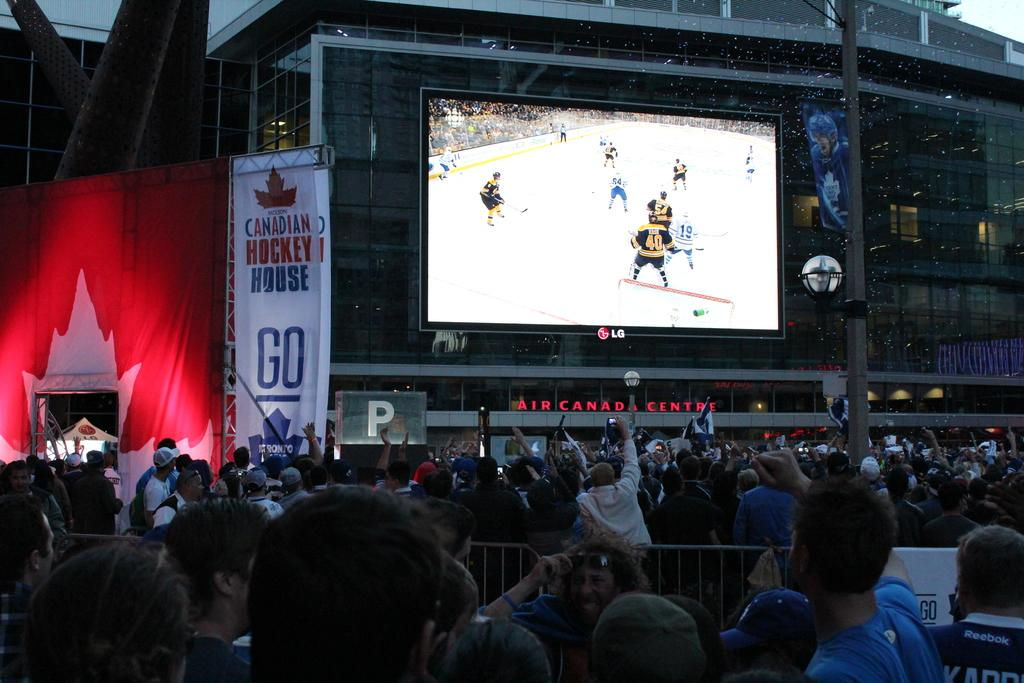What is the main subject in the foreground of the image? There is a crowd in the foreground of the image. Where is the crowd located? The crowd is on the road. What is present in the foreground of the image besides the crowd? There is a fence in the foreground of the image. What can be seen in the background of the image? There is a screen, buildings, a poster, and the sky visible in the background of the image. What type of grass is growing on the screen in the background of the image? There is no grass visible on the screen in the background of the image. What musical instrument is being played by the crowd in the image? There is no musical instrument being played by the crowd in the image. 